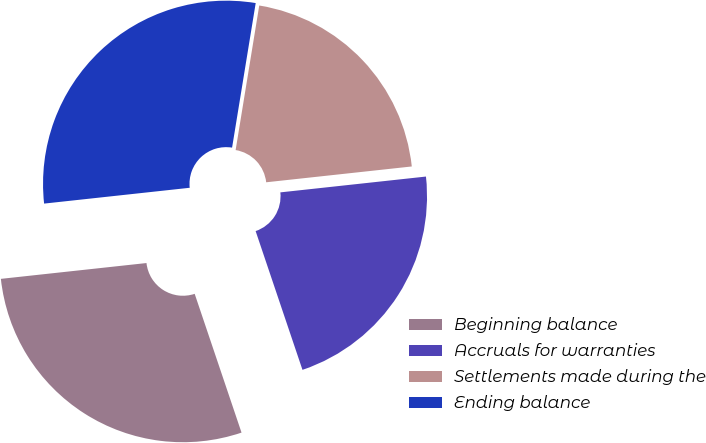Convert chart to OTSL. <chart><loc_0><loc_0><loc_500><loc_500><pie_chart><fcel>Beginning balance<fcel>Accruals for warranties<fcel>Settlements made during the<fcel>Ending balance<nl><fcel>28.46%<fcel>21.54%<fcel>20.7%<fcel>29.3%<nl></chart> 